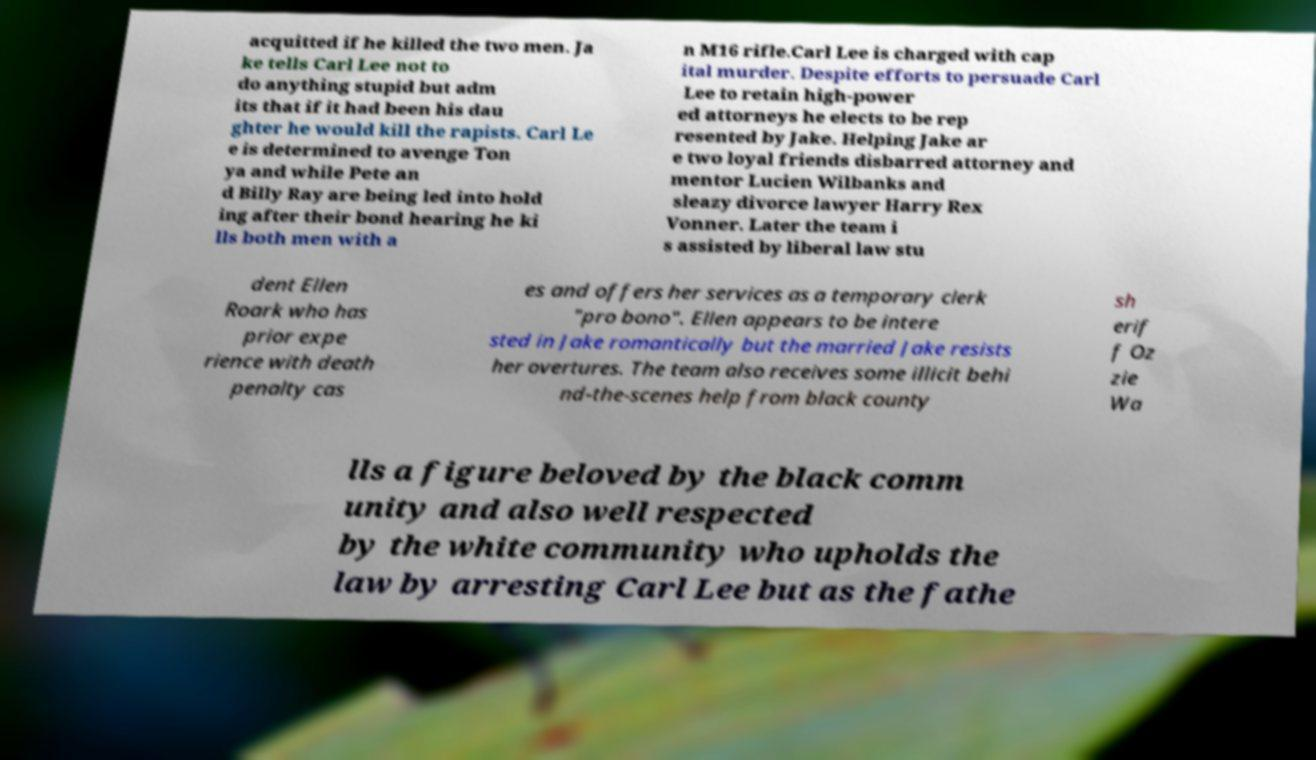Could you assist in decoding the text presented in this image and type it out clearly? acquitted if he killed the two men. Ja ke tells Carl Lee not to do anything stupid but adm its that if it had been his dau ghter he would kill the rapists. Carl Le e is determined to avenge Ton ya and while Pete an d Billy Ray are being led into hold ing after their bond hearing he ki lls both men with a n M16 rifle.Carl Lee is charged with cap ital murder. Despite efforts to persuade Carl Lee to retain high-power ed attorneys he elects to be rep resented by Jake. Helping Jake ar e two loyal friends disbarred attorney and mentor Lucien Wilbanks and sleazy divorce lawyer Harry Rex Vonner. Later the team i s assisted by liberal law stu dent Ellen Roark who has prior expe rience with death penalty cas es and offers her services as a temporary clerk "pro bono". Ellen appears to be intere sted in Jake romantically but the married Jake resists her overtures. The team also receives some illicit behi nd-the-scenes help from black county sh erif f Oz zie Wa lls a figure beloved by the black comm unity and also well respected by the white community who upholds the law by arresting Carl Lee but as the fathe 